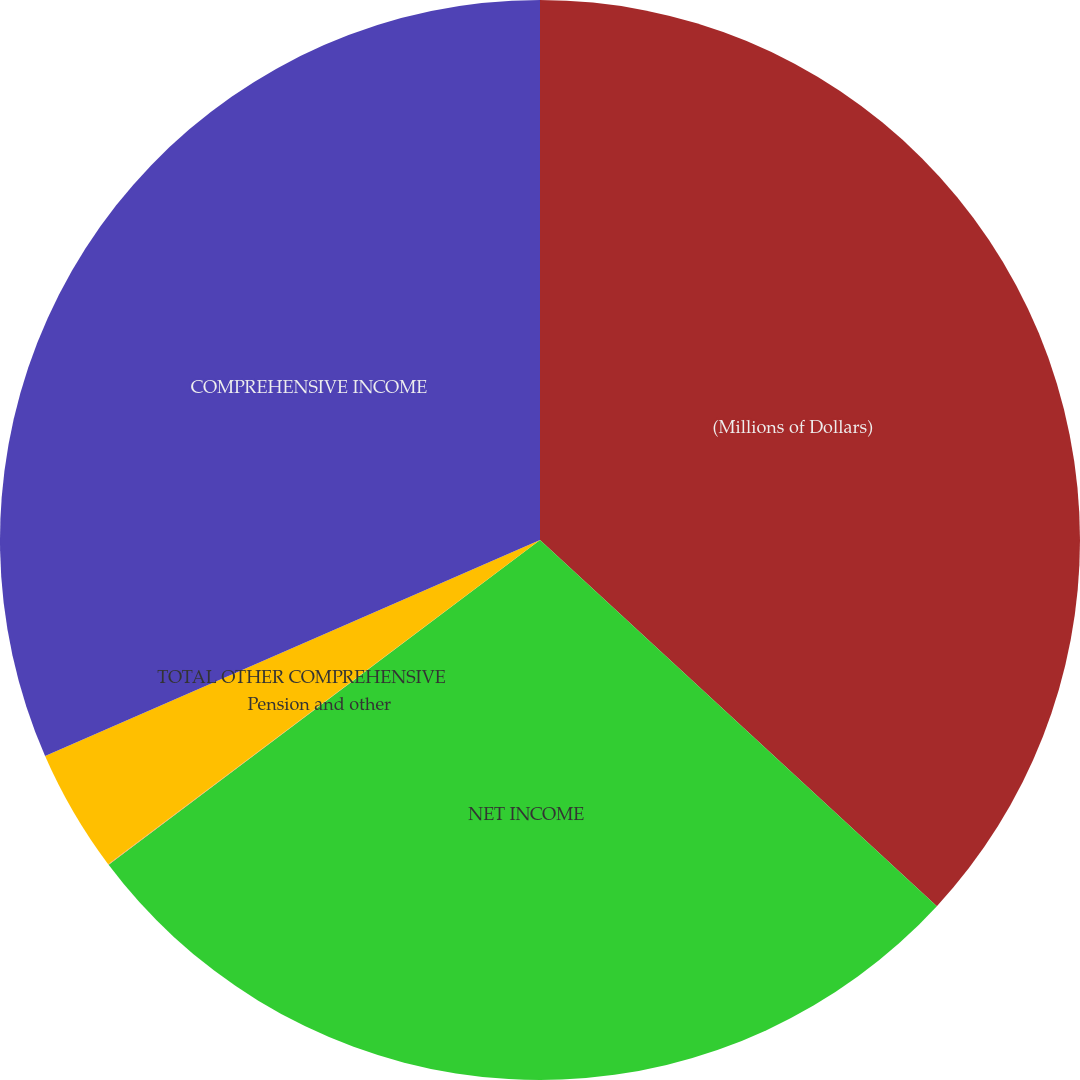<chart> <loc_0><loc_0><loc_500><loc_500><pie_chart><fcel>(Millions of Dollars)<fcel>NET INCOME<fcel>Pension and other<fcel>TOTAL OTHER COMPREHENSIVE<fcel>COMPREHENSIVE INCOME<nl><fcel>36.86%<fcel>27.87%<fcel>0.02%<fcel>3.7%<fcel>31.55%<nl></chart> 